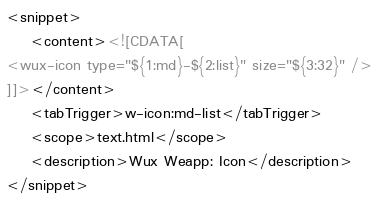<code> <loc_0><loc_0><loc_500><loc_500><_XML_><snippet>
	<content><![CDATA[
<wux-icon type="${1:md}-${2:list}" size="${3:32}" />
]]></content>
	<tabTrigger>w-icon:md-list</tabTrigger>
	<scope>text.html</scope>
	<description>Wux Weapp: Icon</description>
</snippet></code> 